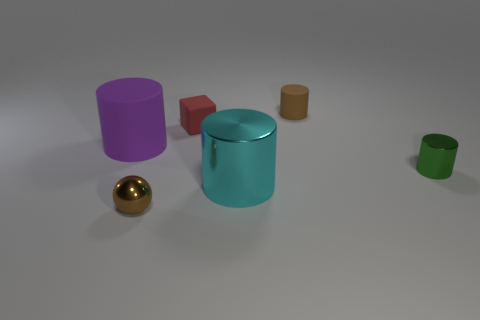Subtract all large metallic cylinders. How many cylinders are left? 3 Add 3 cyan metallic cylinders. How many objects exist? 9 Subtract all purple cylinders. How many cylinders are left? 3 Subtract all cylinders. How many objects are left? 2 Add 5 tiny red rubber cubes. How many tiny red rubber cubes exist? 6 Subtract 0 cyan blocks. How many objects are left? 6 Subtract all blue cylinders. Subtract all blue cubes. How many cylinders are left? 4 Subtract all large cyan things. Subtract all brown matte cylinders. How many objects are left? 4 Add 1 brown rubber objects. How many brown rubber objects are left? 2 